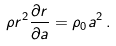<formula> <loc_0><loc_0><loc_500><loc_500>\rho r ^ { 2 } \frac { \partial r } { \partial a } = \rho _ { 0 } a ^ { 2 } \, .</formula> 